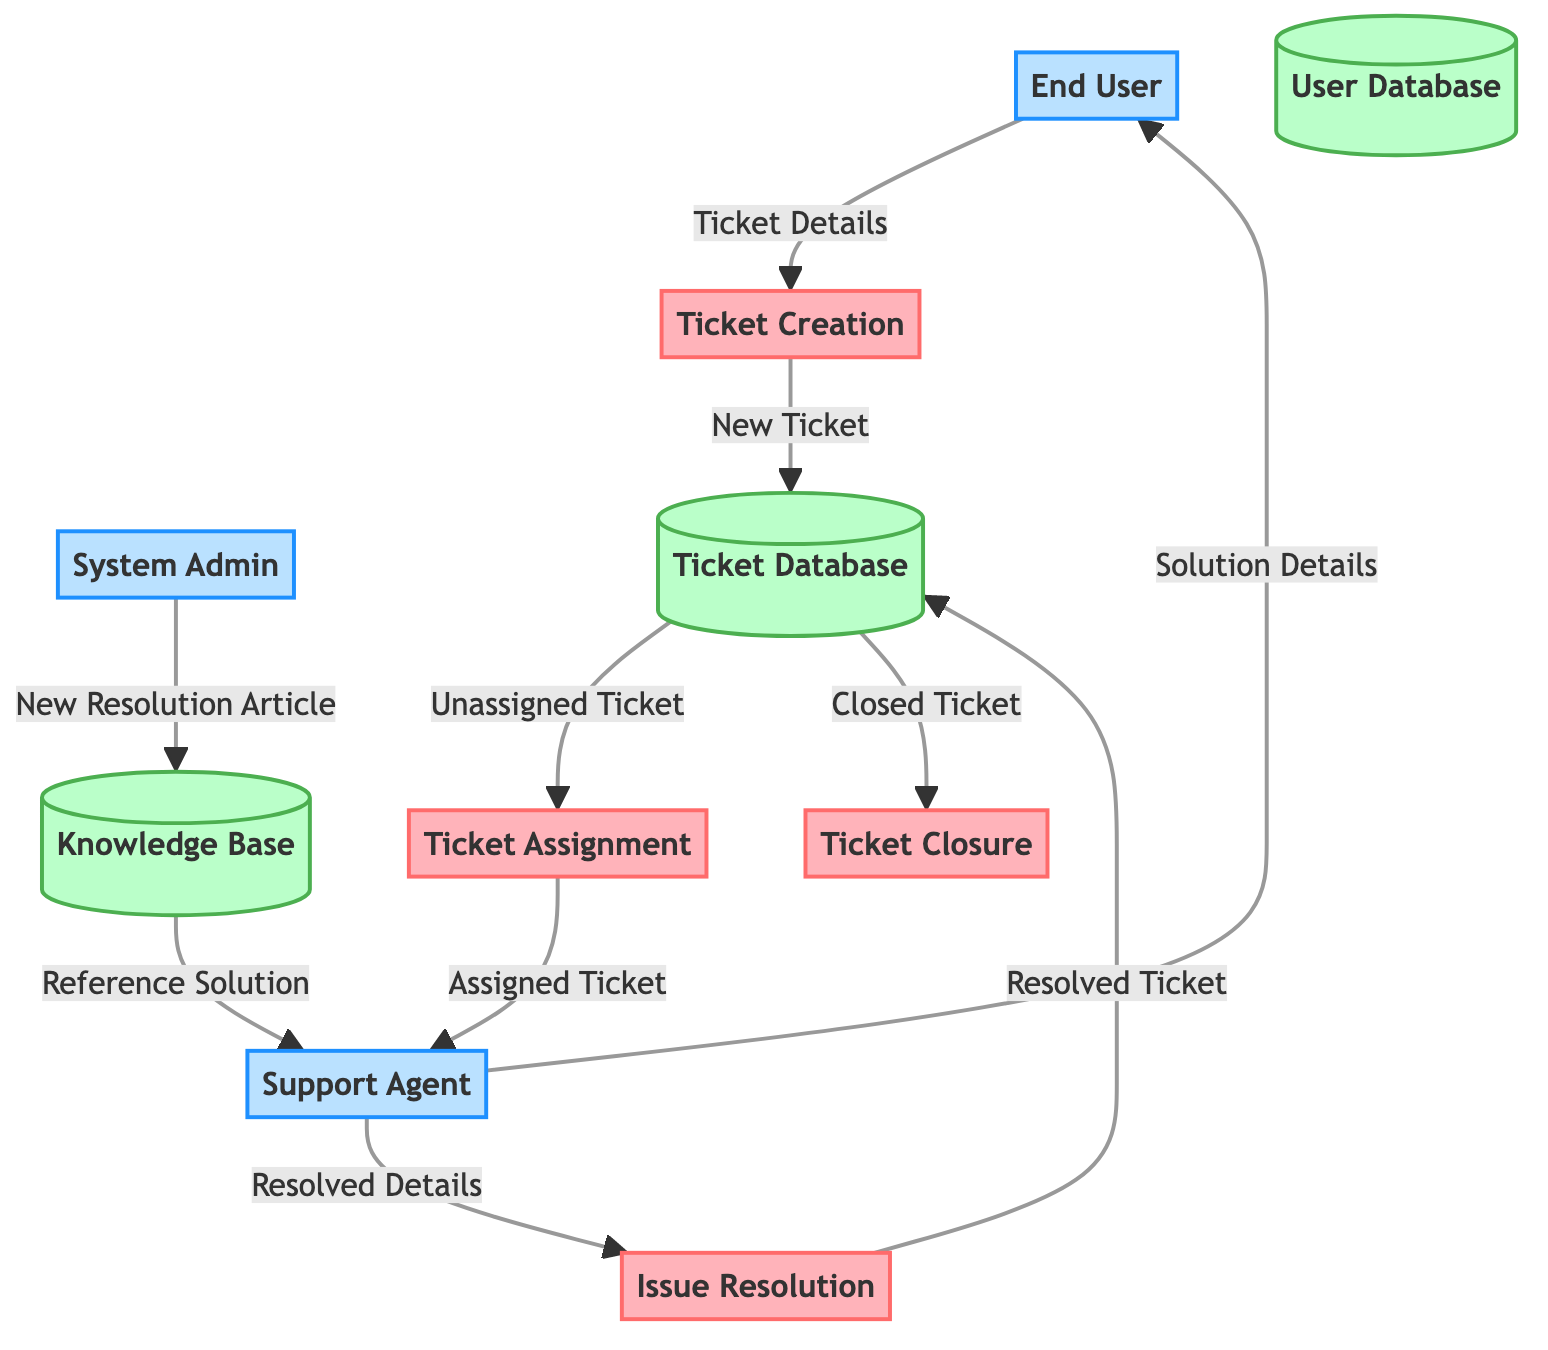What is the first process in the diagram? The first process in the diagram is represented by the node "Ticket Creation," which is the starting point for the flow of the ticketing system.
Answer: Ticket Creation How many external entities are present in this diagram? By counting the nodes designated as external entities, there are three: End User, Support Agent, and System Admin.
Answer: 3 What does the End User provide to the Ticket Creation process? The relationship between the End User and the Ticket Creation process indicates that the End User provides "Ticket Details" to initiate a new ticket.
Answer: Ticket Details Which process is responsible for assigning tickets to Support Agents? The process "Ticket Assignment" takes unassigned tickets from the Ticket Database and assigns them to Support Agents, which makes it the responsible process for this action.
Answer: Ticket Assignment What data flows from the Ticket Database to the Ticket Closure process? The data flowing from the Ticket Database to the Ticket Closure process is labeled as "Closed Ticket," showing the transition to closure after resolution.
Answer: Closed Ticket What type of data does the System Admin contribute to the Knowledge Base? The System Admin contributes "New Resolution Article" to the Knowledge Base, enhancing the information available for future reference.
Answer: New Resolution Article How does the Support Agent communicate the solution to the End User? The flow indicates that the Support Agent sends "Solution Details" to the End User, completing the resolution process for the ticket.
Answer: Solution Details What is the last process in this diagram? The last process in the diagram, which concludes the flow of the ticketing system, is "Ticket Closure."
Answer: Ticket Closure Which data store is used to store resolved tickets? The data store named "Ticket Database" is where resolved tickets are stored after they have been processed and resolved by the Support Agent.
Answer: Ticket Database 